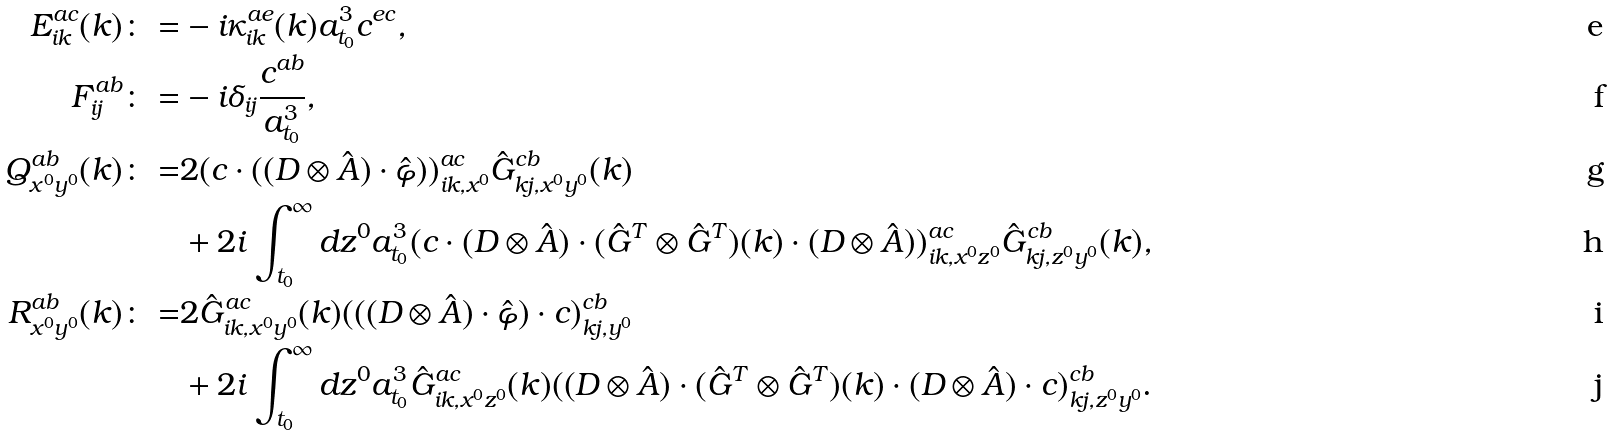Convert formula to latex. <formula><loc_0><loc_0><loc_500><loc_500>E ^ { a c } _ { i k } ( { k } ) \colon = & - i \kappa ^ { a e } _ { i k } ( { k } ) a _ { t _ { 0 } } ^ { 3 } c ^ { e c } , \\ F _ { i j } ^ { a b } \colon = & - i \delta _ { i j } \frac { c ^ { a b } } { a _ { t _ { 0 } } ^ { 3 } } , \\ Q ^ { a b } _ { x ^ { 0 } y ^ { 0 } } ( { k } ) \colon = & 2 ( c \cdot ( ( D \otimes \hat { A } ) \cdot \hat { \varphi } ) ) ^ { a c } _ { i k , x ^ { 0 } } \hat { G } ^ { c b } _ { k j , x ^ { 0 } y ^ { 0 } } ( { k } ) \\ & + 2 i \int ^ { \infty } _ { t _ { 0 } } d z ^ { 0 } a ^ { 3 } _ { t _ { 0 } } ( c \cdot ( D \otimes \hat { A } ) \cdot ( \hat { G } ^ { T } \otimes \hat { G } ^ { T } ) ( { k } ) \cdot ( D \otimes \hat { A } ) ) ^ { a c } _ { i k , x ^ { 0 } z ^ { 0 } } \hat { G } ^ { c b } _ { k j , z ^ { 0 } y ^ { 0 } } ( { k } ) , \\ R ^ { a b } _ { x ^ { 0 } y ^ { 0 } } ( { k } ) \colon = & 2 \hat { G } ^ { a c } _ { i k , x ^ { 0 } y ^ { 0 } } ( { k } ) ( ( ( D \otimes \hat { A } ) \cdot \hat { \varphi } ) \cdot c ) ^ { c b } _ { k j , y ^ { 0 } } \\ & + 2 i \int ^ { \infty } _ { t _ { 0 } } d z ^ { 0 } a ^ { 3 } _ { t _ { 0 } } \hat { G } ^ { a c } _ { i k , x ^ { 0 } z ^ { 0 } } ( { k } ) ( ( D \otimes \hat { A } ) \cdot ( \hat { G } ^ { T } \otimes \hat { G } ^ { T } ) ( { k } ) \cdot ( D \otimes \hat { A } ) \cdot c ) ^ { c b } _ { k j , z ^ { 0 } y ^ { 0 } } .</formula> 